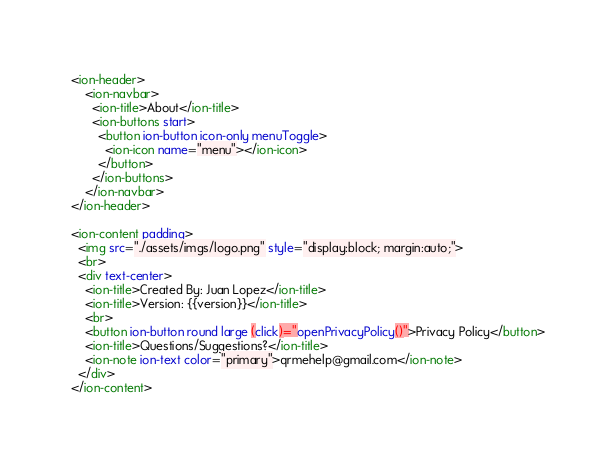Convert code to text. <code><loc_0><loc_0><loc_500><loc_500><_HTML_><ion-header>
    <ion-navbar>
      <ion-title>About</ion-title>
      <ion-buttons start>
        <button ion-button icon-only menuToggle>
          <ion-icon name="menu"></ion-icon>
        </button>
      </ion-buttons>
    </ion-navbar>
</ion-header>

<ion-content padding>
  <img src="./assets/imgs/logo.png" style="display:block; margin:auto;">
  <br>
  <div text-center>
    <ion-title>Created By: Juan Lopez</ion-title>
    <ion-title>Version: {{version}}</ion-title>
    <br>
    <button ion-button round large (click)="openPrivacyPolicy()">Privacy Policy</button>
    <ion-title>Questions/Suggestions?</ion-title>
    <ion-note ion-text color="primary">qrmehelp@gmail.com</ion-note>
  </div>
</ion-content></code> 